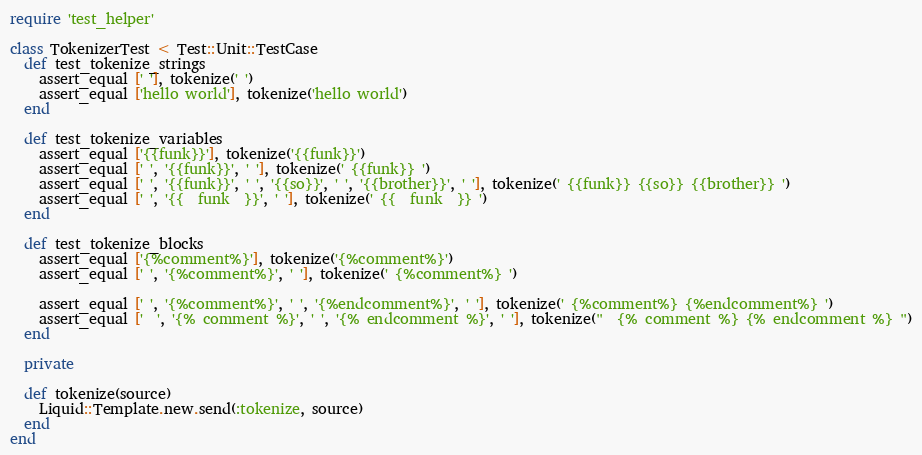Convert code to text. <code><loc_0><loc_0><loc_500><loc_500><_Ruby_>require 'test_helper'

class TokenizerTest < Test::Unit::TestCase
  def test_tokenize_strings
    assert_equal [' '], tokenize(' ')
    assert_equal ['hello world'], tokenize('hello world')
  end

  def test_tokenize_variables
    assert_equal ['{{funk}}'], tokenize('{{funk}}')
    assert_equal [' ', '{{funk}}', ' '], tokenize(' {{funk}} ')
    assert_equal [' ', '{{funk}}', ' ', '{{so}}', ' ', '{{brother}}', ' '], tokenize(' {{funk}} {{so}} {{brother}} ')
    assert_equal [' ', '{{  funk  }}', ' '], tokenize(' {{  funk  }} ')
  end

  def test_tokenize_blocks
    assert_equal ['{%comment%}'], tokenize('{%comment%}')
    assert_equal [' ', '{%comment%}', ' '], tokenize(' {%comment%} ')

    assert_equal [' ', '{%comment%}', ' ', '{%endcomment%}', ' '], tokenize(' {%comment%} {%endcomment%} ')
    assert_equal ['  ', '{% comment %}', ' ', '{% endcomment %}', ' '], tokenize("  {% comment %} {% endcomment %} ")
  end

  private

  def tokenize(source)
    Liquid::Template.new.send(:tokenize, source)
  end
end
</code> 